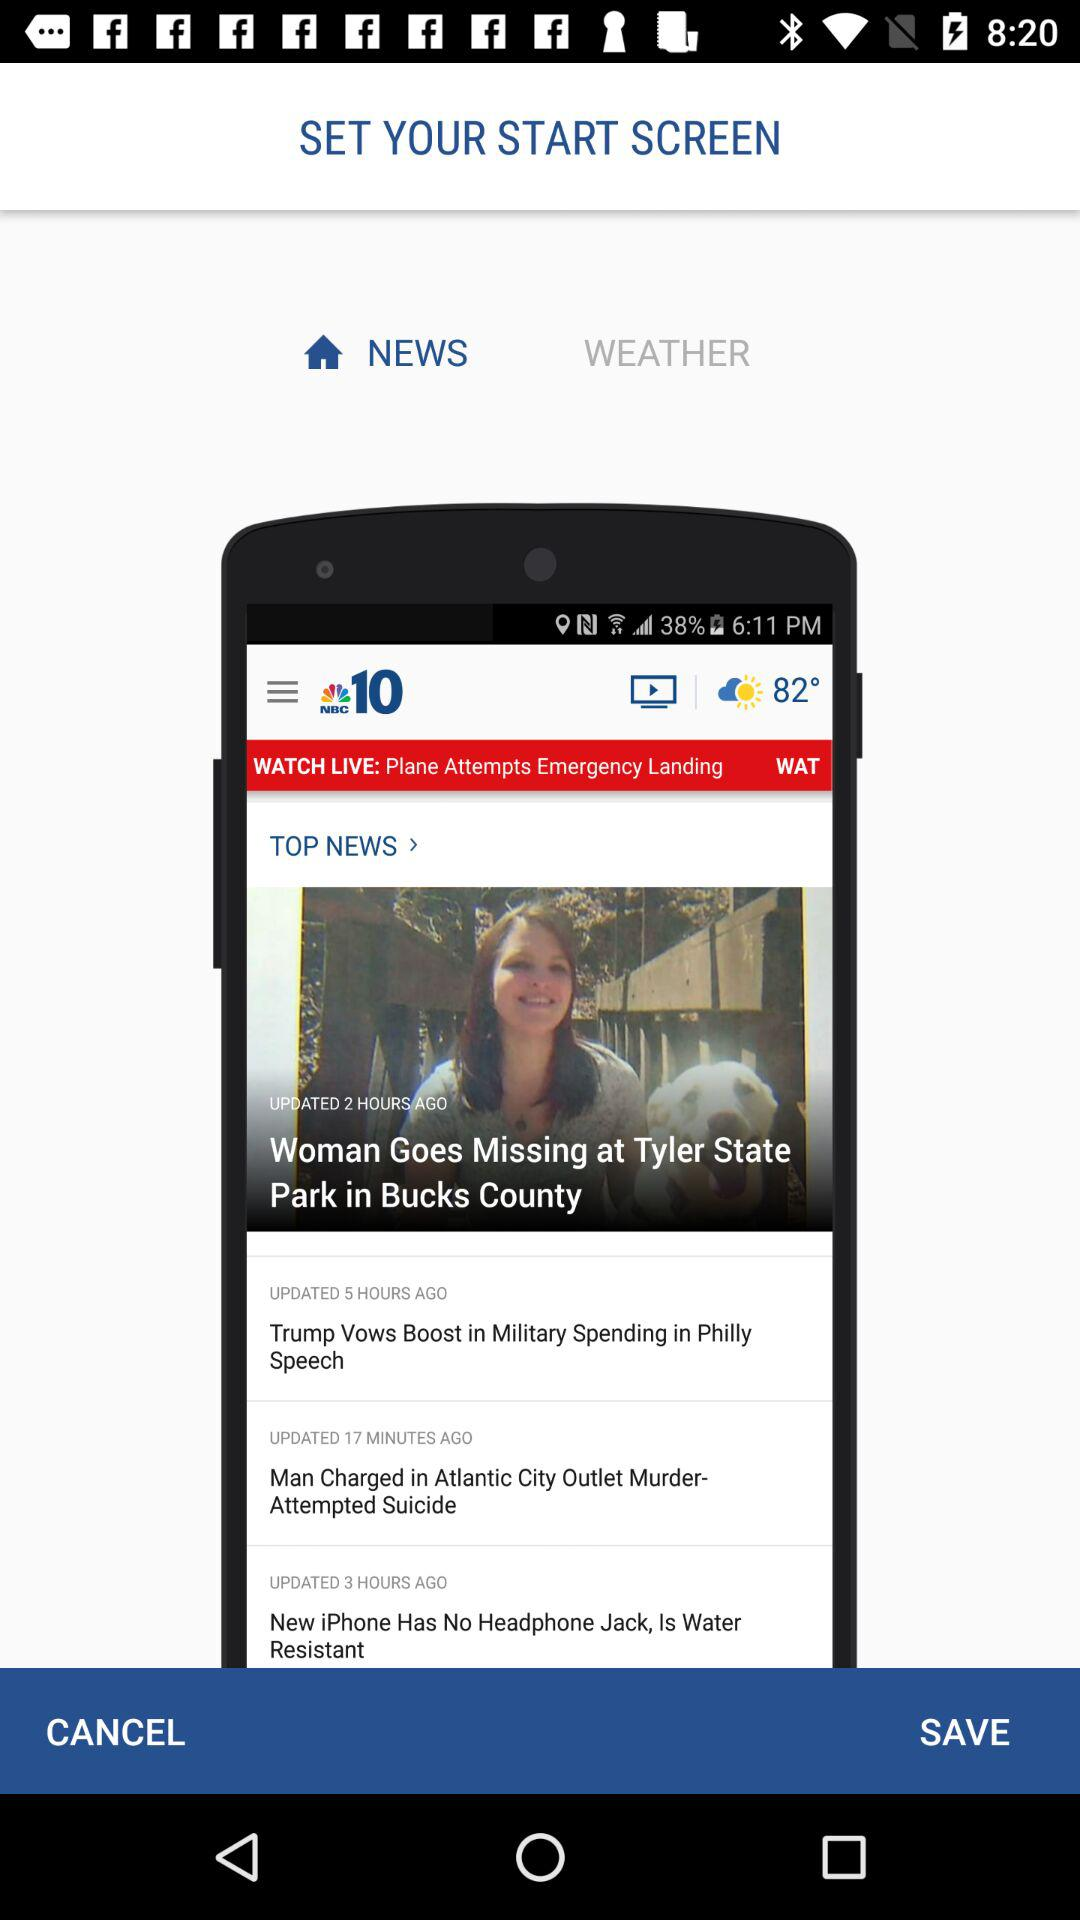What is the temperature? The temperature is 82°. 